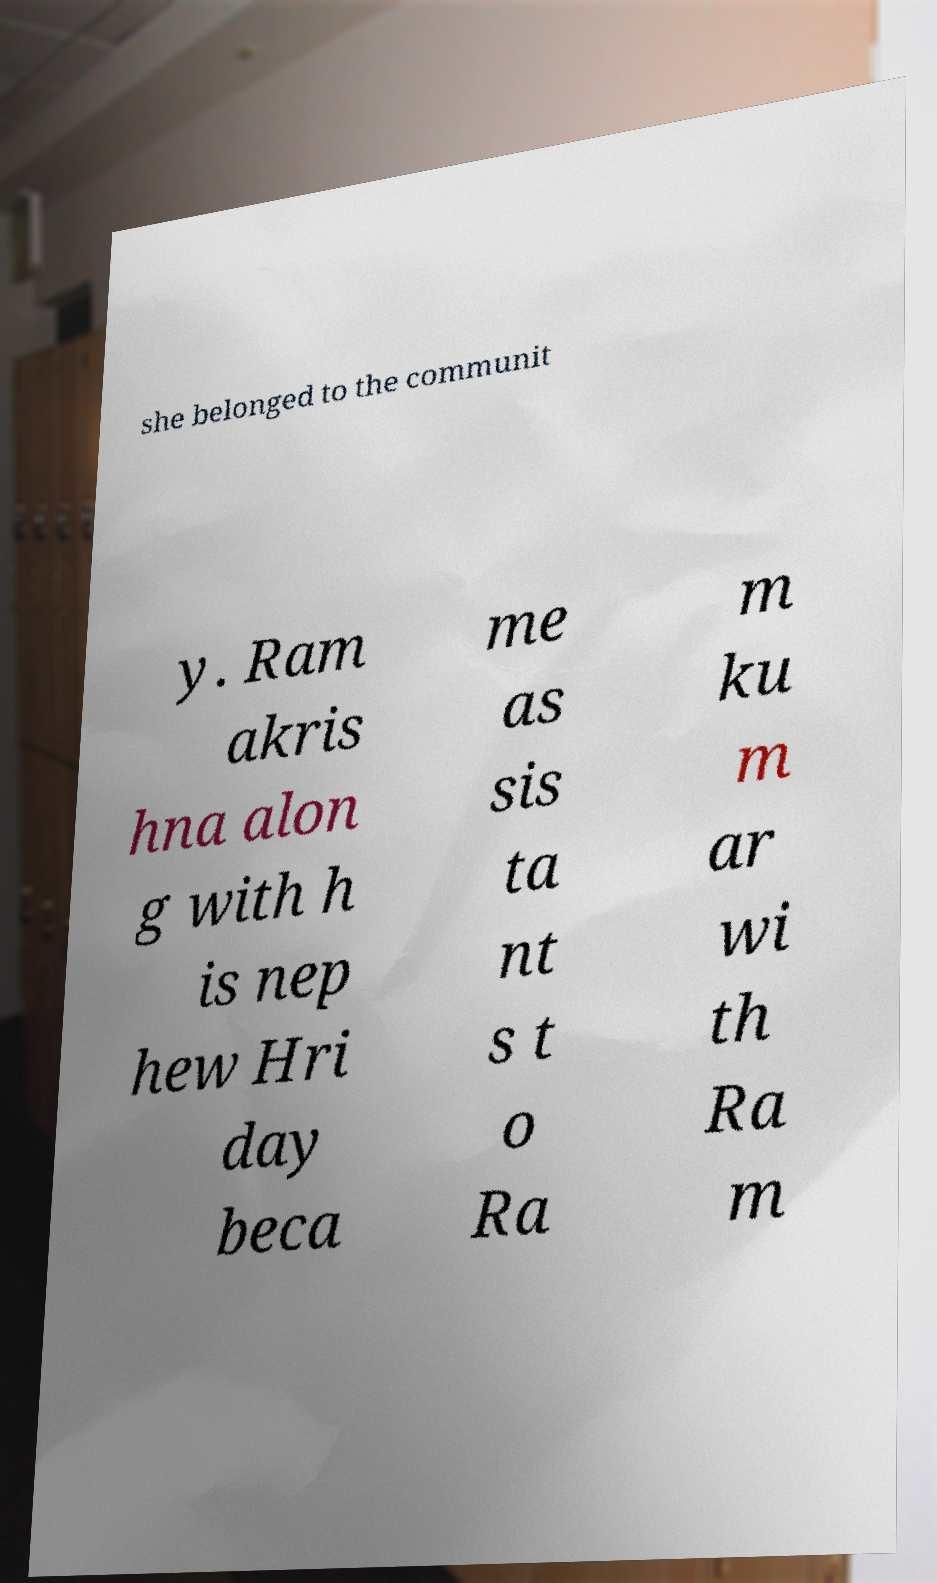Can you read and provide the text displayed in the image?This photo seems to have some interesting text. Can you extract and type it out for me? she belonged to the communit y. Ram akris hna alon g with h is nep hew Hri day beca me as sis ta nt s t o Ra m ku m ar wi th Ra m 